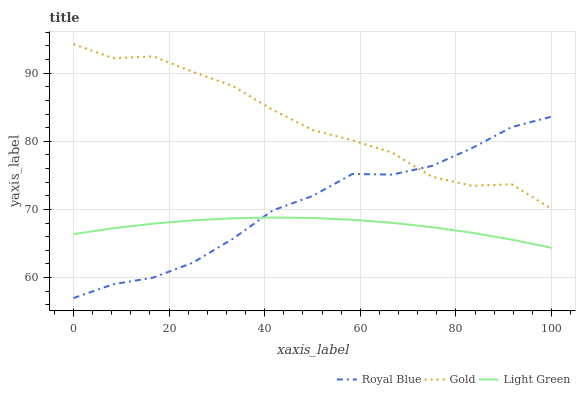Does Light Green have the minimum area under the curve?
Answer yes or no. Yes. Does Gold have the maximum area under the curve?
Answer yes or no. Yes. Does Gold have the minimum area under the curve?
Answer yes or no. No. Does Light Green have the maximum area under the curve?
Answer yes or no. No. Is Light Green the smoothest?
Answer yes or no. Yes. Is Gold the roughest?
Answer yes or no. Yes. Is Gold the smoothest?
Answer yes or no. No. Is Light Green the roughest?
Answer yes or no. No. Does Royal Blue have the lowest value?
Answer yes or no. Yes. Does Light Green have the lowest value?
Answer yes or no. No. Does Gold have the highest value?
Answer yes or no. Yes. Does Light Green have the highest value?
Answer yes or no. No. Is Light Green less than Gold?
Answer yes or no. Yes. Is Gold greater than Light Green?
Answer yes or no. Yes. Does Royal Blue intersect Gold?
Answer yes or no. Yes. Is Royal Blue less than Gold?
Answer yes or no. No. Is Royal Blue greater than Gold?
Answer yes or no. No. Does Light Green intersect Gold?
Answer yes or no. No. 